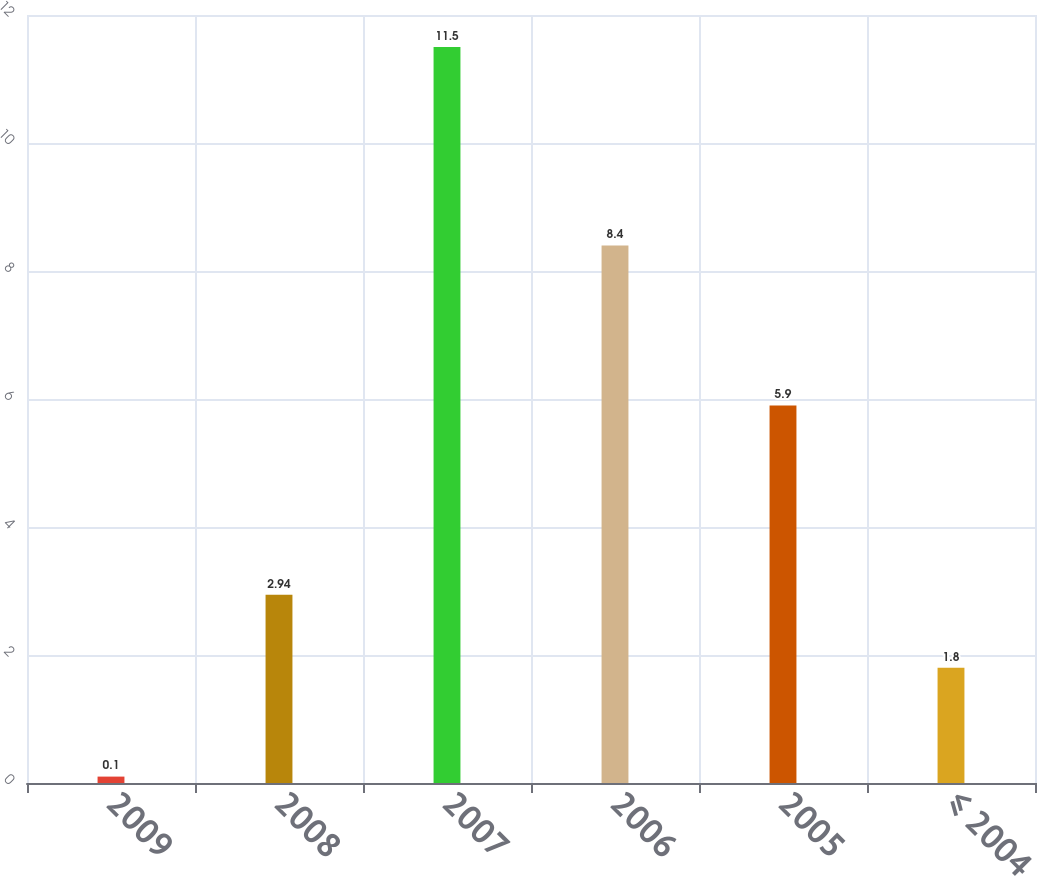Convert chart. <chart><loc_0><loc_0><loc_500><loc_500><bar_chart><fcel>2009<fcel>2008<fcel>2007<fcel>2006<fcel>2005<fcel>≤ 2004<nl><fcel>0.1<fcel>2.94<fcel>11.5<fcel>8.4<fcel>5.9<fcel>1.8<nl></chart> 